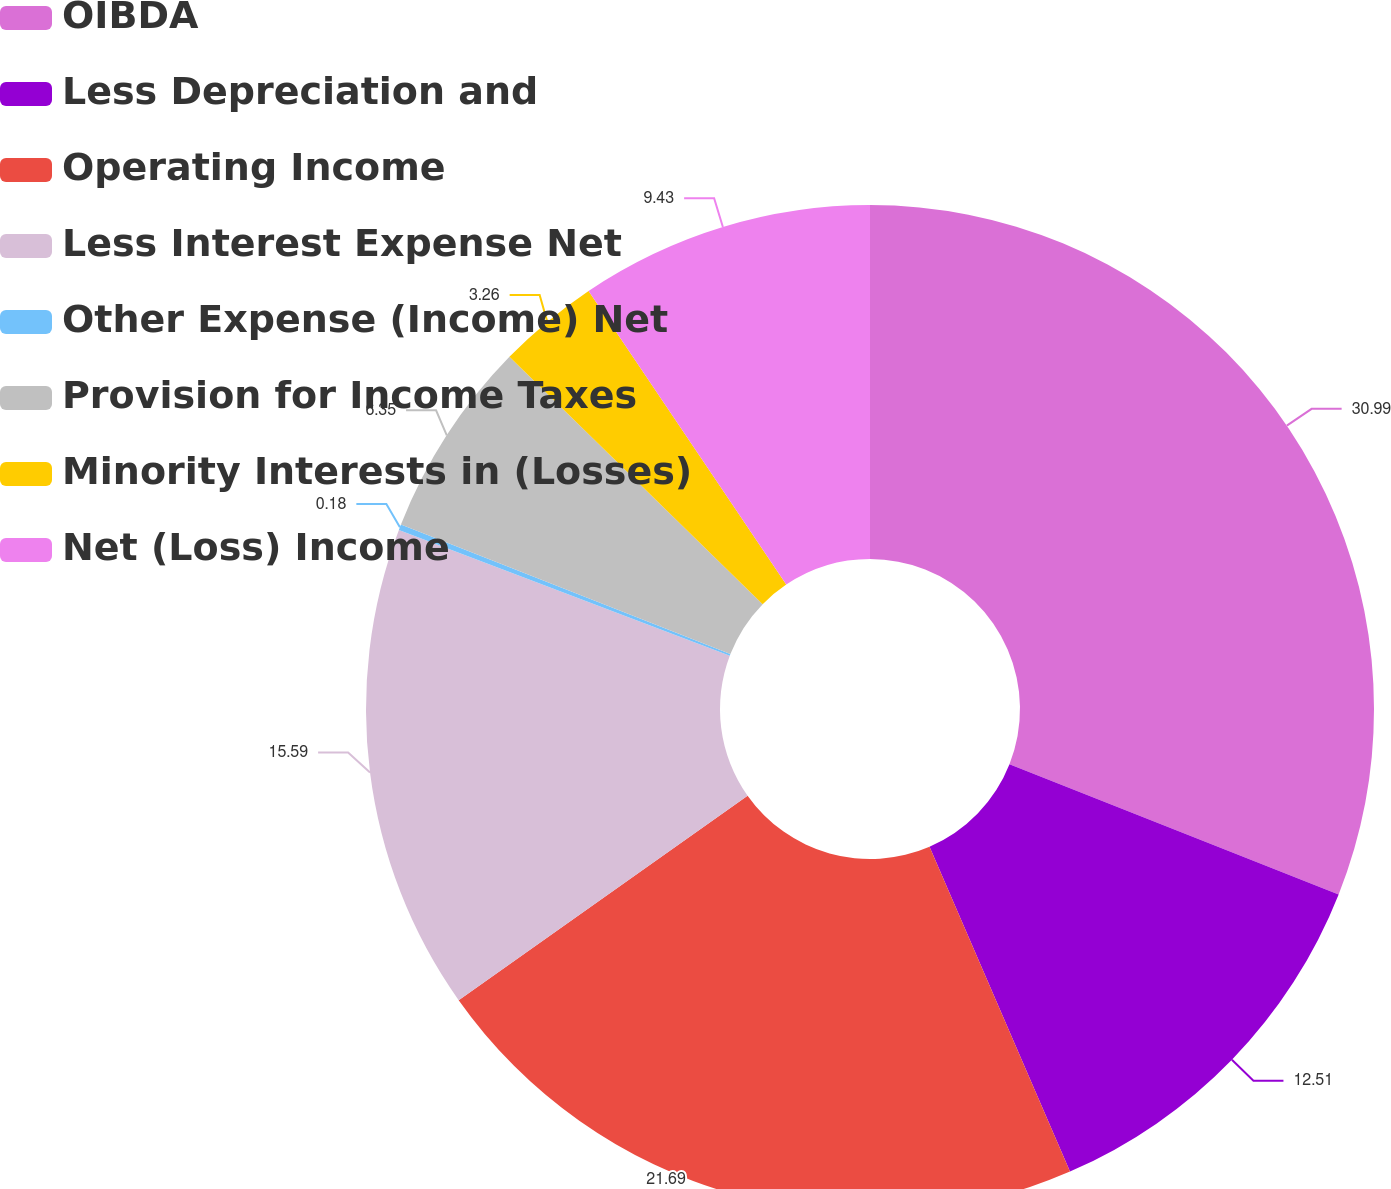<chart> <loc_0><loc_0><loc_500><loc_500><pie_chart><fcel>OIBDA<fcel>Less Depreciation and<fcel>Operating Income<fcel>Less Interest Expense Net<fcel>Other Expense (Income) Net<fcel>Provision for Income Taxes<fcel>Minority Interests in (Losses)<fcel>Net (Loss) Income<nl><fcel>31.0%<fcel>12.51%<fcel>21.69%<fcel>15.59%<fcel>0.18%<fcel>6.35%<fcel>3.26%<fcel>9.43%<nl></chart> 